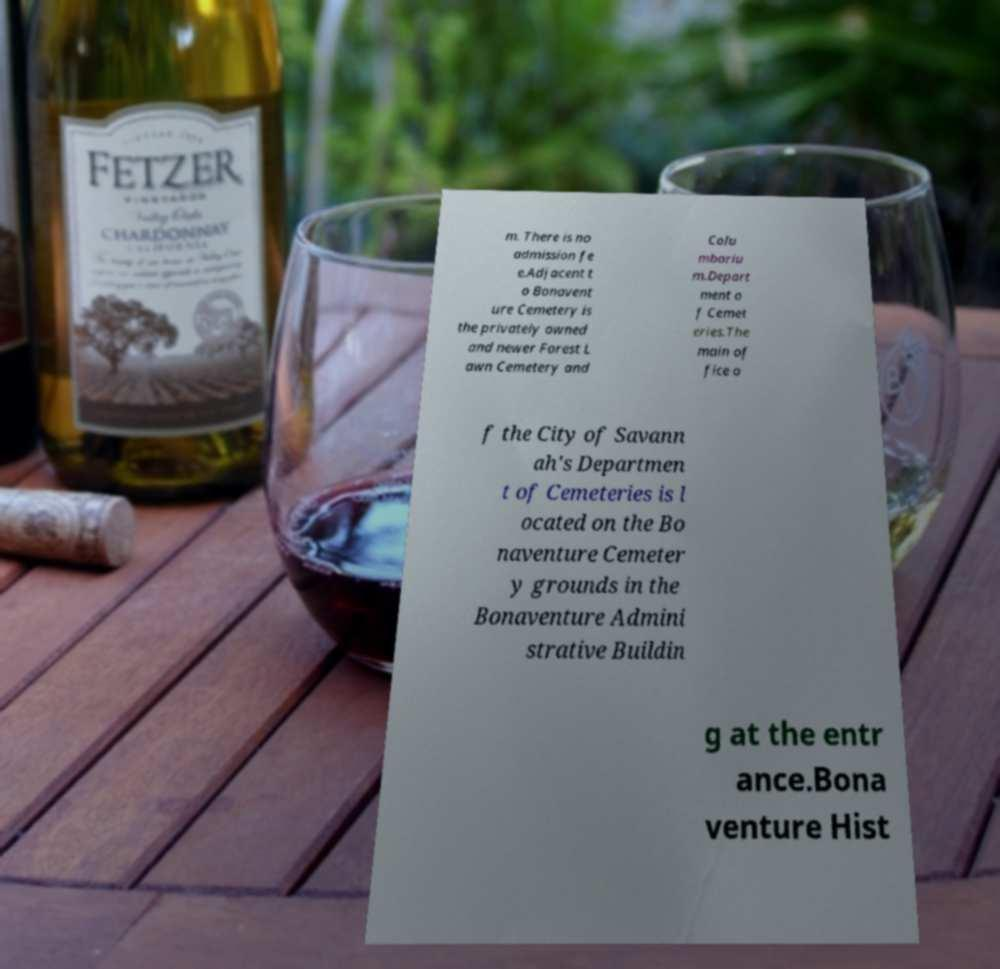There's text embedded in this image that I need extracted. Can you transcribe it verbatim? m. There is no admission fe e.Adjacent t o Bonavent ure Cemetery is the privately owned and newer Forest L awn Cemetery and Colu mbariu m.Depart ment o f Cemet eries.The main of fice o f the City of Savann ah's Departmen t of Cemeteries is l ocated on the Bo naventure Cemeter y grounds in the Bonaventure Admini strative Buildin g at the entr ance.Bona venture Hist 